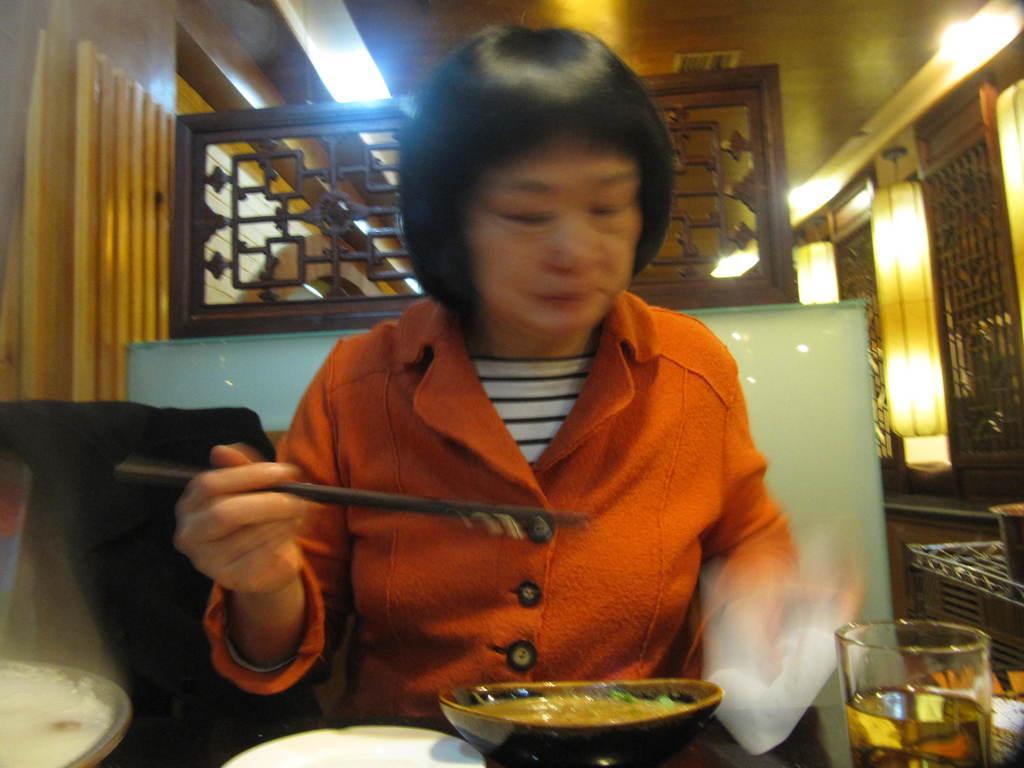In one or two sentences, can you explain what this image depicts? In this image we can see a lady holding chopsticks, in front of her there are food items in the bowls, there is a glass of drink, also we can see the walls, lights, and a grille. 